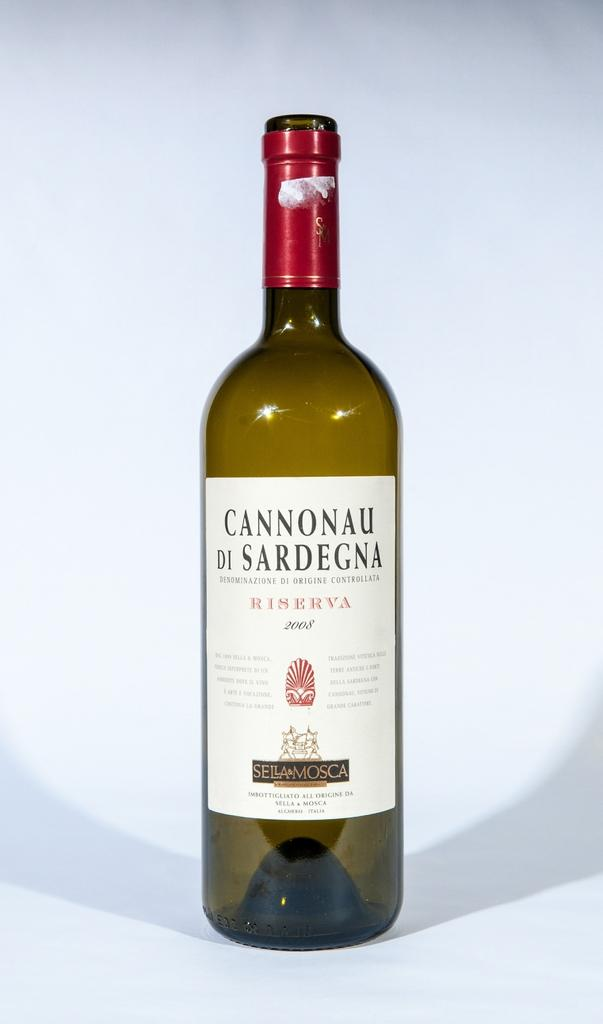<image>
Share a concise interpretation of the image provided. An empty bottle of Cannonau di Sardegna sits on a table. 